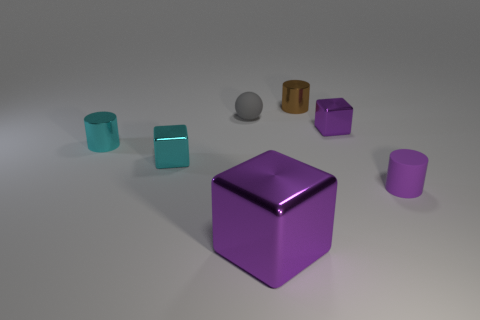Add 3 big metal objects. How many objects exist? 10 Subtract all spheres. How many objects are left? 6 Add 5 blocks. How many blocks are left? 8 Add 1 matte balls. How many matte balls exist? 2 Subtract 0 gray blocks. How many objects are left? 7 Subtract all tiny gray metallic things. Subtract all purple rubber objects. How many objects are left? 6 